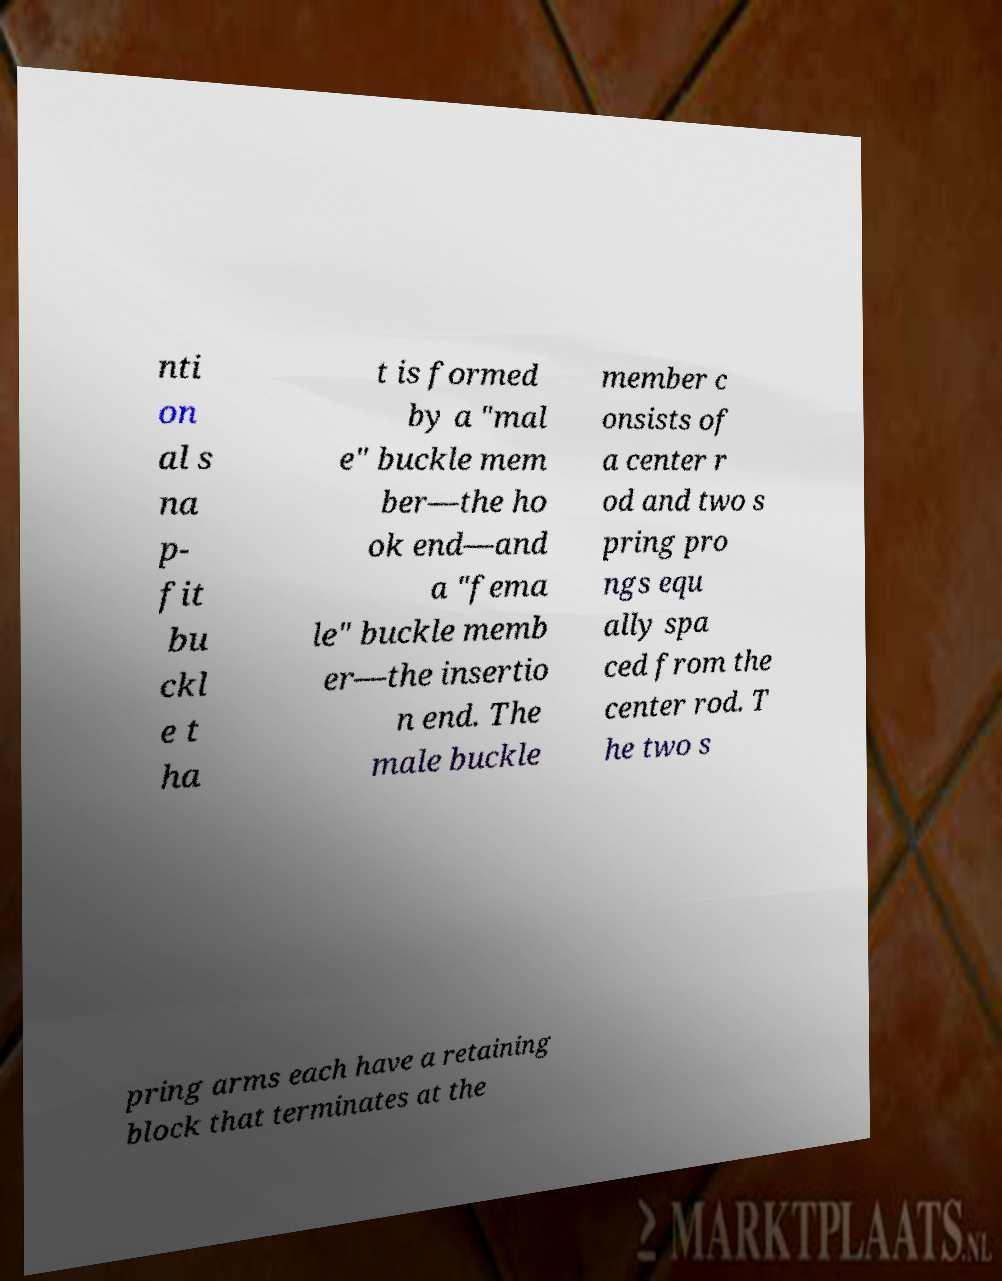Please read and relay the text visible in this image. What does it say? nti on al s na p- fit bu ckl e t ha t is formed by a "mal e" buckle mem ber—the ho ok end—and a "fema le" buckle memb er—the insertio n end. The male buckle member c onsists of a center r od and two s pring pro ngs equ ally spa ced from the center rod. T he two s pring arms each have a retaining block that terminates at the 